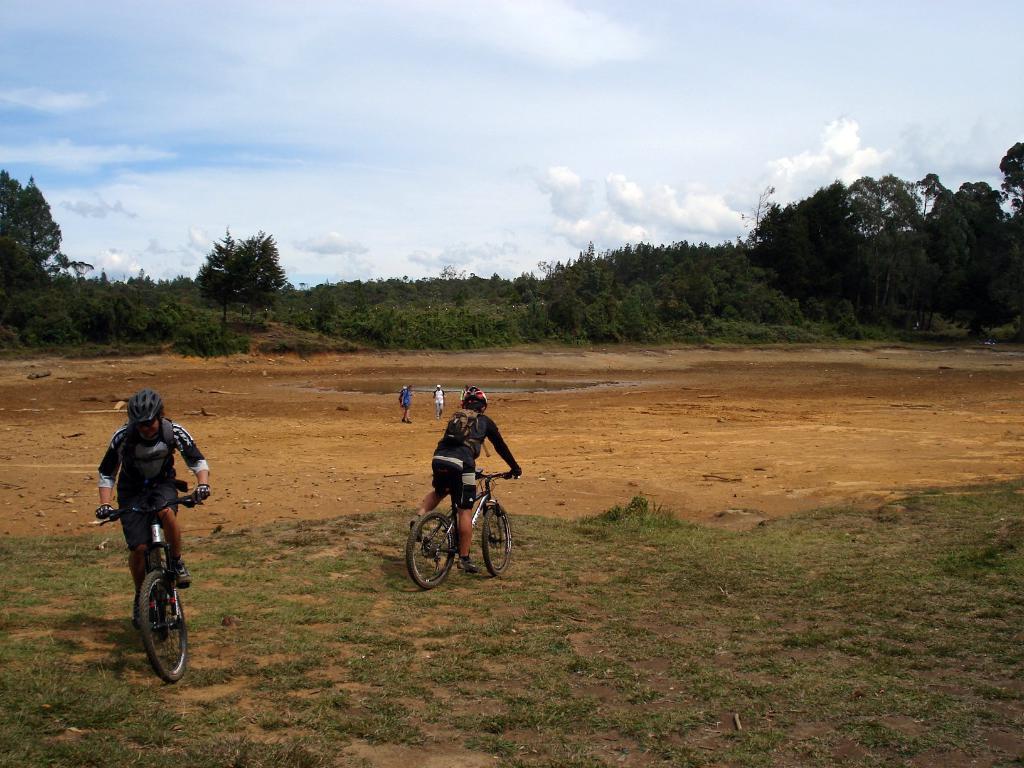Can you describe this image briefly? This picture shows trees and couple of them standing and we see trees and couple of them riding bicycles and they wore helmets on their heads and we see grass on the ground and a cloudy sky. 